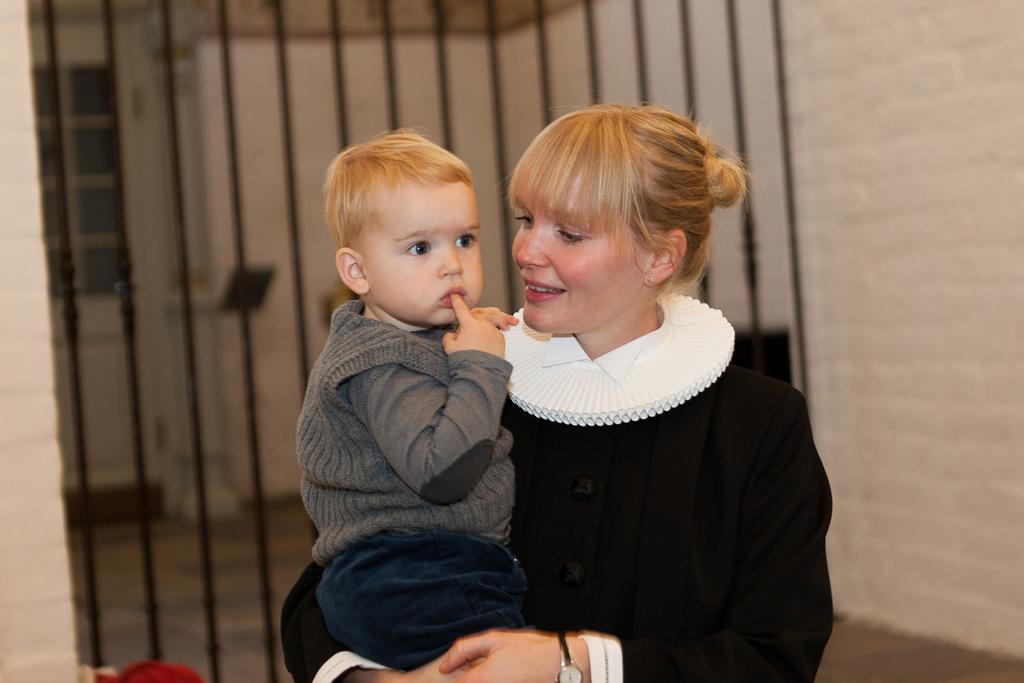Who is present in the image? There is a woman in the image. What is the woman doing in the image? The woman is holding a boy. What expression does the woman have in the image? The woman is smiling. What can be seen in the background of the image? There is a grille, a floor, and a wall visible in the background of the image. What is visible through the grille in the background? A door is visible through the grille. What idea does the woman have for improving the throat health of the boy in the image? There is no indication in the image that the woman has any specific idea for improving the throat health of the boy. 